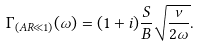Convert formula to latex. <formula><loc_0><loc_0><loc_500><loc_500>\Gamma _ { ( A R \ll 1 ) } ( \omega ) = ( 1 + i ) \frac { S } { B } \sqrt { \frac { \nu } { 2 \omega } } .</formula> 